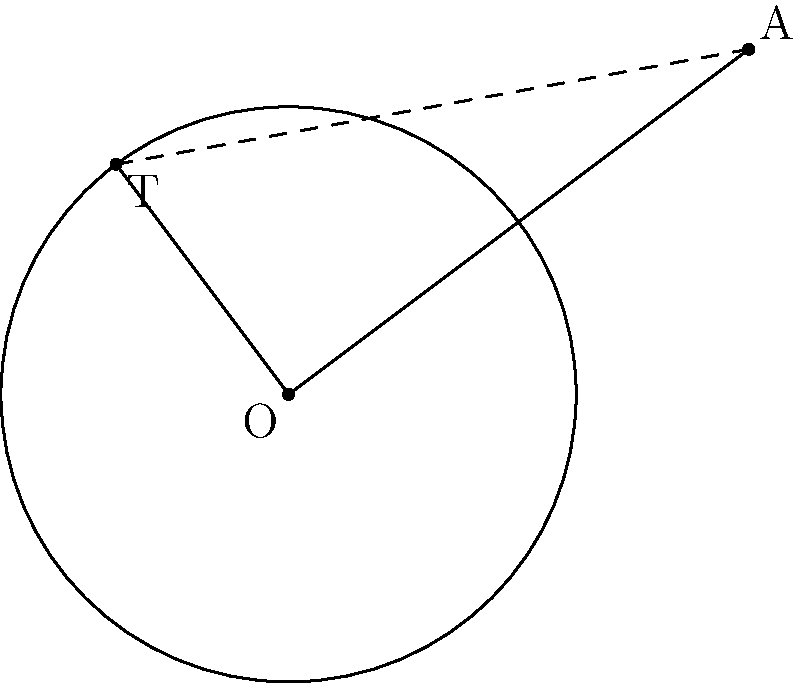In a particle detector setup, a magnetic field is applied perpendicular to a circular region with radius $r = 2.5$ cm. A particle's trajectory is represented by a line passing through point $A$, located $5$ cm from the center $O$ of the circular region. Calculate the length of the tangent line $x$ from point $A$ to the circle, which represents the closest approach of the particle to the edge of the magnetic field. To solve this problem, we can use the theorem of tangent-secant lengths and the Pythagorean theorem. Let's approach this step-by-step:

1) Let $d$ be the distance from $O$ to $A$. We're given that $d = 5$ cm and $r = 2.5$ cm.

2) The theorem of tangent-secant lengths states that for a tangent line from an external point to a circle: $x^2 = d^2 - r^2$, where $x$ is the length of the tangent line.

3) Substituting the known values:
   $x^2 = 5^2 - 2.5^2$

4) Simplify:
   $x^2 = 25 - 6.25 = 18.75$

5) Take the square root of both sides:
   $x = \sqrt{18.75}$

6) Simplify the square root:
   $x = \sqrt{18.75} = \frac{\sqrt{75}}{2} = \frac{5\sqrt{3}}{2}$

Therefore, the length of the tangent line $x$, representing the closest approach of the particle to the edge of the magnetic field, is $\frac{5\sqrt{3}}{2}$ cm.
Answer: $\frac{5\sqrt{3}}{2}$ cm 